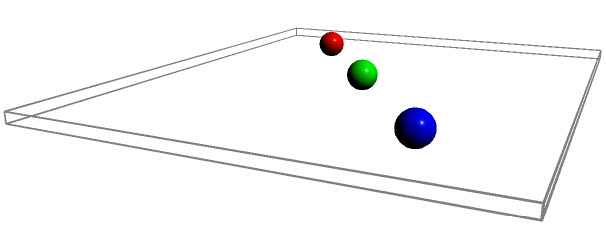As a playwright, you're planning the spatial arrangement for a crucial scene. The stage is represented by a 10x8 meter rectangle. Three actors (A, B, and C) and two props (P1 and P2) are positioned as shown. If actor C needs to move to a position equidistant from both props while maintaining at least 2 meters distance from each other actor, what is the area (in square meters) of the possible region where actor C can stand? To solve this problem, we need to follow these steps:

1. Identify the constraints:
   - Actor C must be equidistant from both props (P1 and P2)
   - Actor C must maintain at least 2 meters distance from actors A and B

2. Find the line of points equidistant from P1 and P2:
   - This is the perpendicular bisector of the line segment connecting P1 and P2
   - P1 is at (3,5) and P2 is at (7,3)
   - Midpoint: $(\frac{3+7}{2}, \frac{5+3}{2}) = (5,4)$
   - Slope of P1P2: $m = \frac{3-5}{7-3} = -\frac{1}{2}$
   - Perpendicular slope: $m_{\perp} = 2$
   - Equation of perpendicular bisector: $y - 4 = 2(x - 5)$

3. Draw circles with radius 2 meters around actors A and B:
   - Circle A: $(x-2)^2 + (y-2)^2 = 4$
   - Circle B: $(x-8)^2 + (y-6)^2 = 4$

4. The possible region for actor C is the part of the perpendicular bisector that:
   - Lies within the stage boundaries (0 ≤ x ≤ 10, 0 ≤ y ≤ 8)
   - Is outside both circles A and B

5. Solve for the intersection points:
   - With stage boundaries: (2.5, 1) and (7.5, 9)
   - With circle A: (3.17, 2.34) and (4.83, 5.66)
   - With circle B: (5.17, 4.34) and (6.83, 7.66)

6. The valid segment is between points (4.83, 5.66) and (6.83, 7.66)

7. Calculate the length of this segment:
   $L = \sqrt{(6.83-4.83)^2 + (7.66-5.66)^2} = 2.83$ meters

8. As this is a line segment, the area is effectively zero. However, in practical terms, we can consider a narrow strip of, say, 0.5 meters wide along this line.

9. The area of this strip would be:
   $A = 2.83 \times 0.5 = 1.415$ square meters
Answer: 1.42 m² 